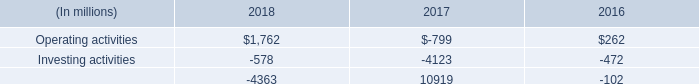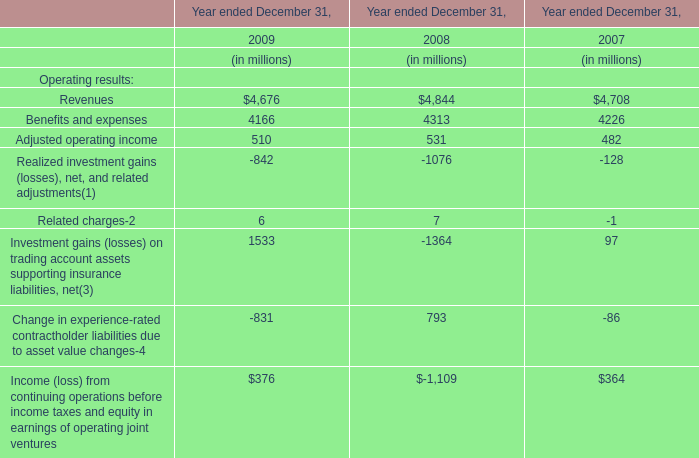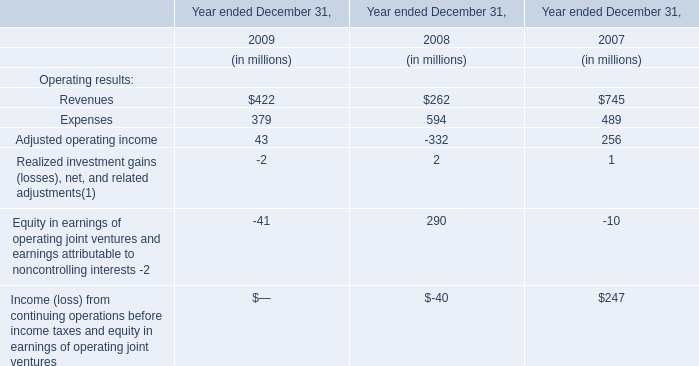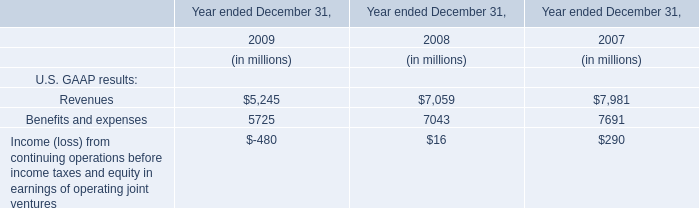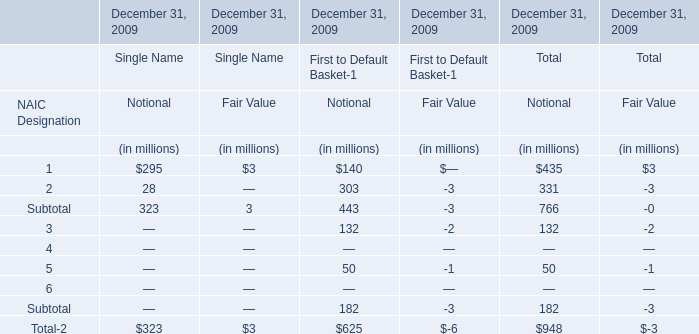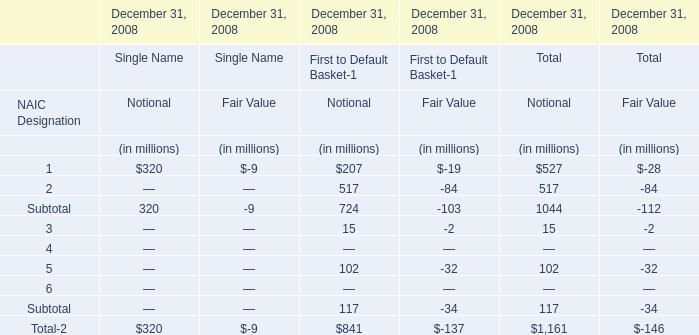What's the 50 % of the value of the Notional for Total NAIC Designation in terms of First to Default Basket at December 31, 2009? (in million) 
Computations: (0.5 * 625)
Answer: 312.5. 